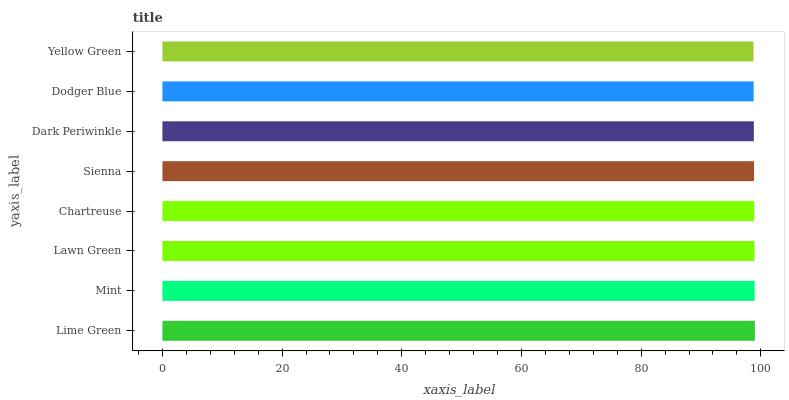Is Yellow Green the minimum?
Answer yes or no. Yes. Is Lime Green the maximum?
Answer yes or no. Yes. Is Mint the minimum?
Answer yes or no. No. Is Mint the maximum?
Answer yes or no. No. Is Lime Green greater than Mint?
Answer yes or no. Yes. Is Mint less than Lime Green?
Answer yes or no. Yes. Is Mint greater than Lime Green?
Answer yes or no. No. Is Lime Green less than Mint?
Answer yes or no. No. Is Chartreuse the high median?
Answer yes or no. Yes. Is Sienna the low median?
Answer yes or no. Yes. Is Lawn Green the high median?
Answer yes or no. No. Is Dark Periwinkle the low median?
Answer yes or no. No. 